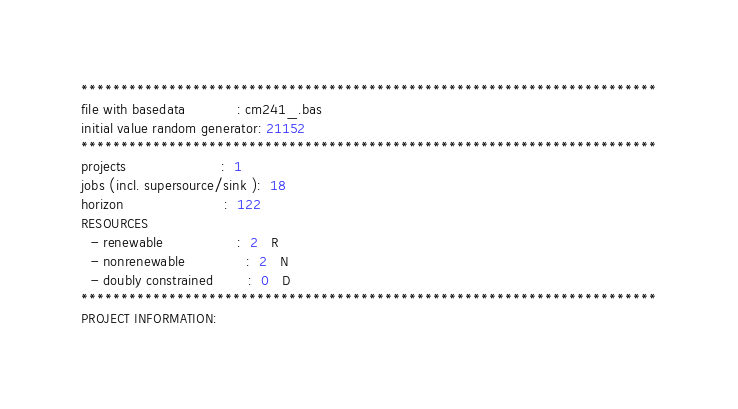Convert code to text. <code><loc_0><loc_0><loc_500><loc_500><_ObjectiveC_>************************************************************************
file with basedata            : cm241_.bas
initial value random generator: 21152
************************************************************************
projects                      :  1
jobs (incl. supersource/sink ):  18
horizon                       :  122
RESOURCES
  - renewable                 :  2   R
  - nonrenewable              :  2   N
  - doubly constrained        :  0   D
************************************************************************
PROJECT INFORMATION:</code> 